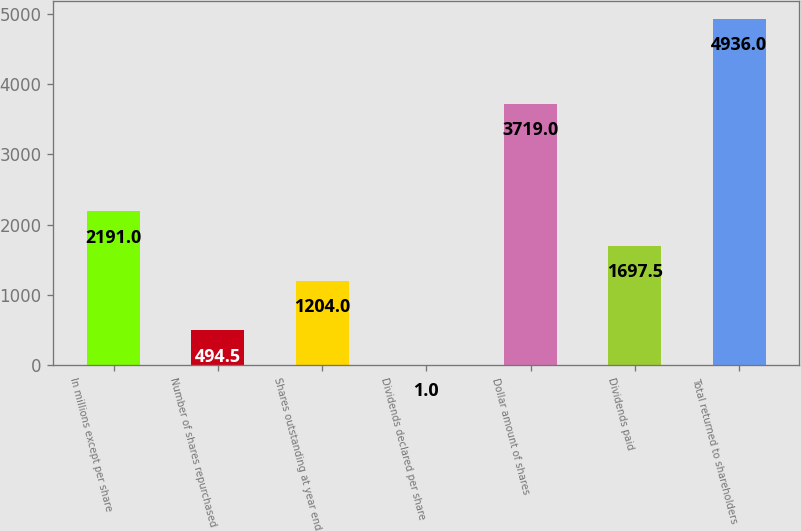<chart> <loc_0><loc_0><loc_500><loc_500><bar_chart><fcel>In millions except per share<fcel>Number of shares repurchased<fcel>Shares outstanding at year end<fcel>Dividends declared per share<fcel>Dollar amount of shares<fcel>Dividends paid<fcel>Total returned to shareholders<nl><fcel>2191<fcel>494.5<fcel>1204<fcel>1<fcel>3719<fcel>1697.5<fcel>4936<nl></chart> 